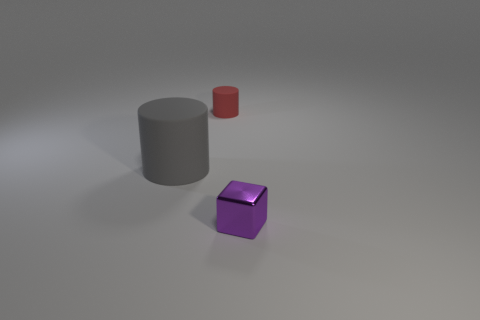There is a object to the left of the tiny object to the left of the small shiny object; what is it made of?
Keep it short and to the point. Rubber. What size is the gray thing that is the same shape as the small red object?
Make the answer very short. Large. Are there fewer large green metal cylinders than big things?
Make the answer very short. Yes. How many other objects are the same color as the small metallic block?
Ensure brevity in your answer.  0. Is the material of the tiny thing that is behind the tiny shiny object the same as the gray thing?
Provide a succinct answer. Yes. What is the small object that is behind the purple thing made of?
Give a very brief answer. Rubber. There is a rubber thing that is in front of the cylinder on the right side of the big gray cylinder; how big is it?
Your answer should be compact. Large. Are there any large brown cylinders made of the same material as the tiny red thing?
Offer a terse response. No. What shape is the tiny thing that is left of the small object that is in front of the tiny thing that is behind the purple thing?
Your answer should be compact. Cylinder. Are there any other things that have the same size as the gray matte object?
Offer a very short reply. No. 